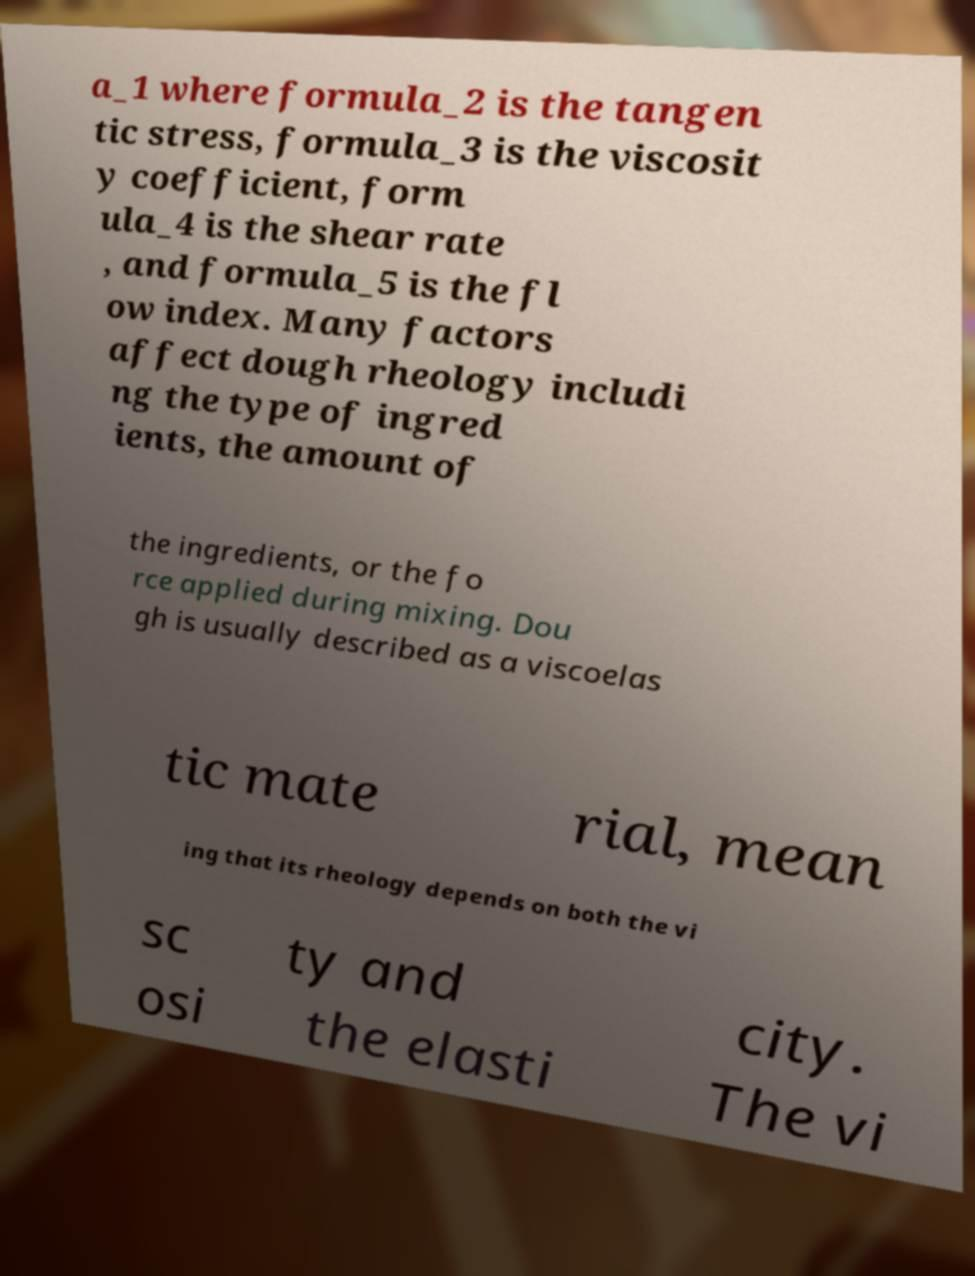Could you extract and type out the text from this image? a_1 where formula_2 is the tangen tic stress, formula_3 is the viscosit y coefficient, form ula_4 is the shear rate , and formula_5 is the fl ow index. Many factors affect dough rheology includi ng the type of ingred ients, the amount of the ingredients, or the fo rce applied during mixing. Dou gh is usually described as a viscoelas tic mate rial, mean ing that its rheology depends on both the vi sc osi ty and the elasti city. The vi 